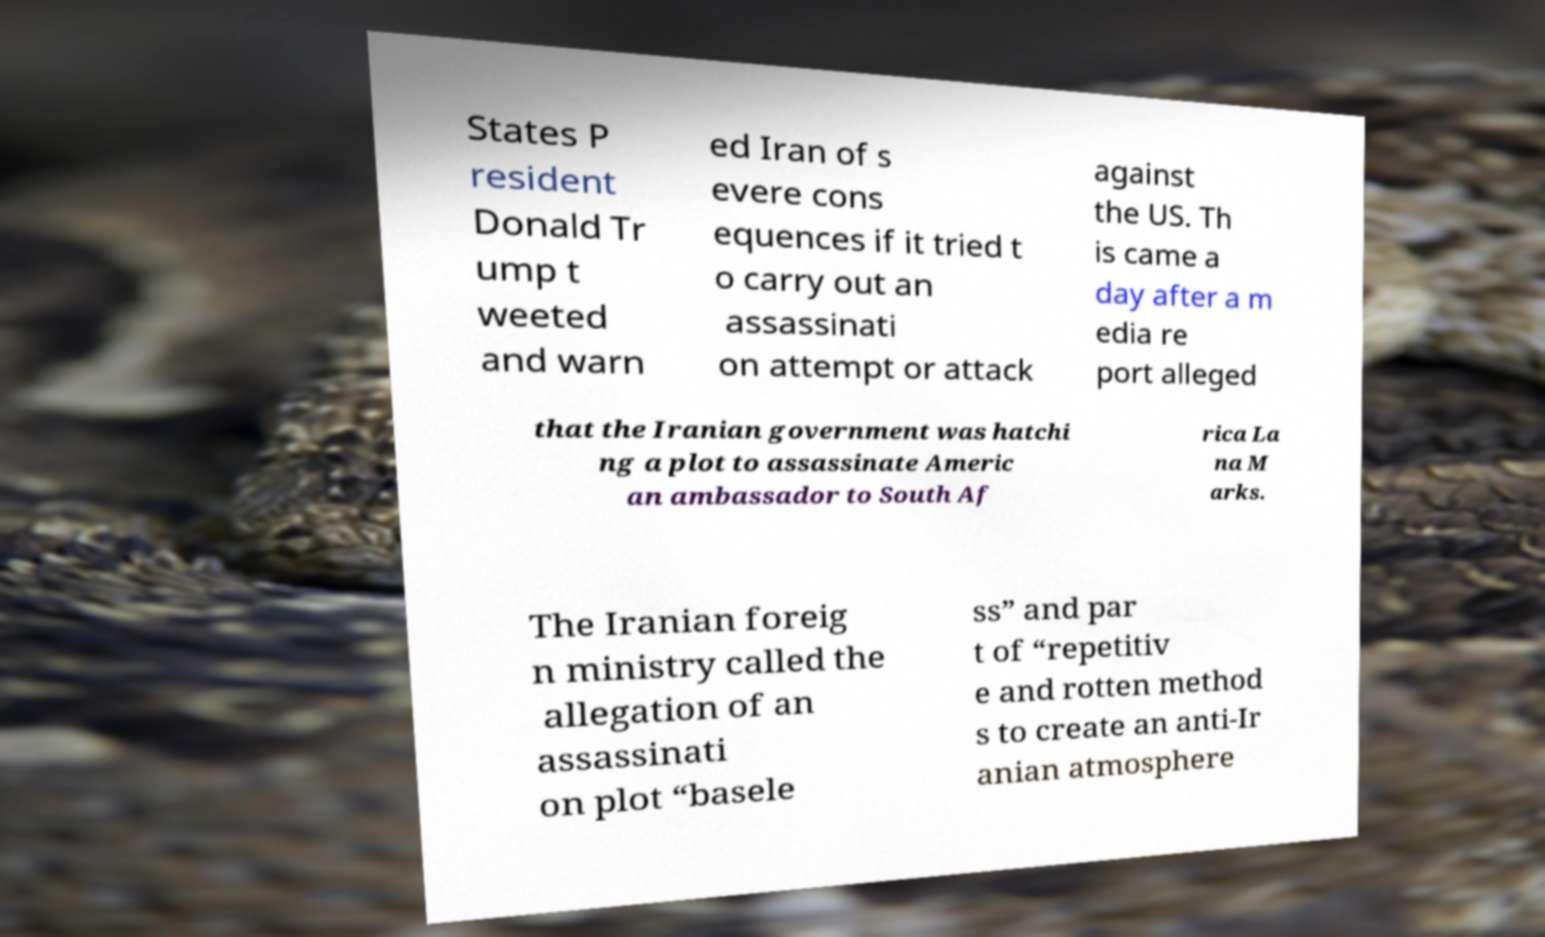Can you read and provide the text displayed in the image?This photo seems to have some interesting text. Can you extract and type it out for me? States P resident Donald Tr ump t weeted and warn ed Iran of s evere cons equences if it tried t o carry out an assassinati on attempt or attack against the US. Th is came a day after a m edia re port alleged that the Iranian government was hatchi ng a plot to assassinate Americ an ambassador to South Af rica La na M arks. The Iranian foreig n ministry called the allegation of an assassinati on plot “basele ss” and par t of “repetitiv e and rotten method s to create an anti-Ir anian atmosphere 